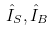Convert formula to latex. <formula><loc_0><loc_0><loc_500><loc_500>\hat { I } _ { S } , \hat { I } _ { B }</formula> 